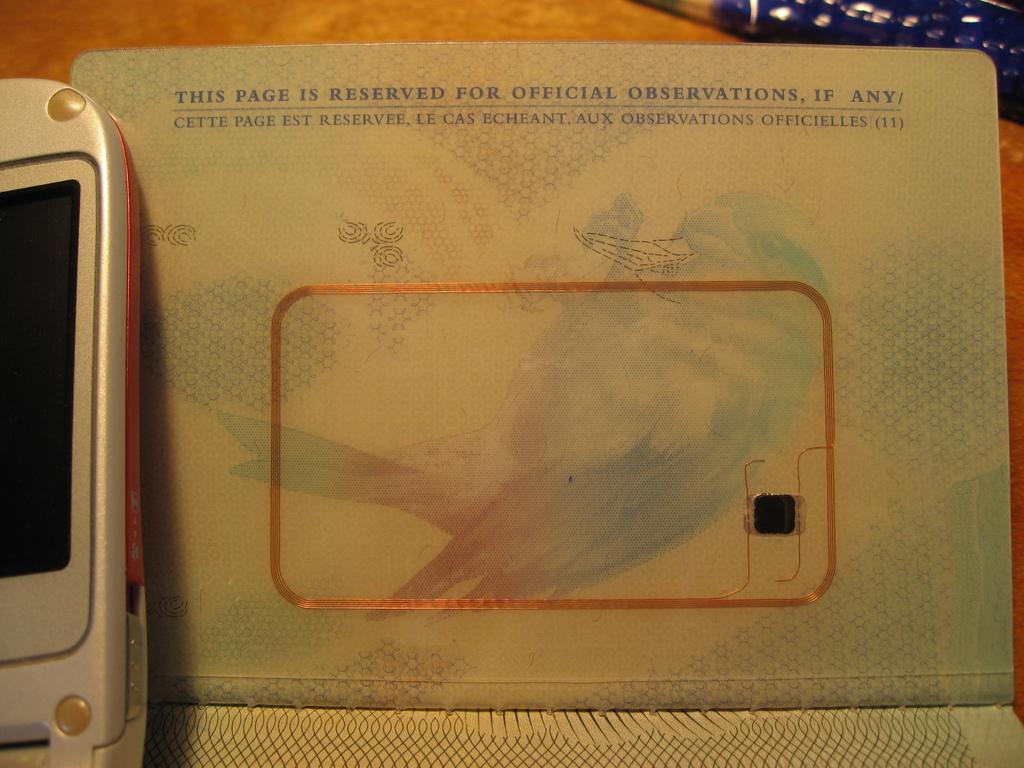What is this page reserved for?
Give a very brief answer. Official observations. What is written on the top line?
Provide a short and direct response. This page is reserved for official observations, if any/. 